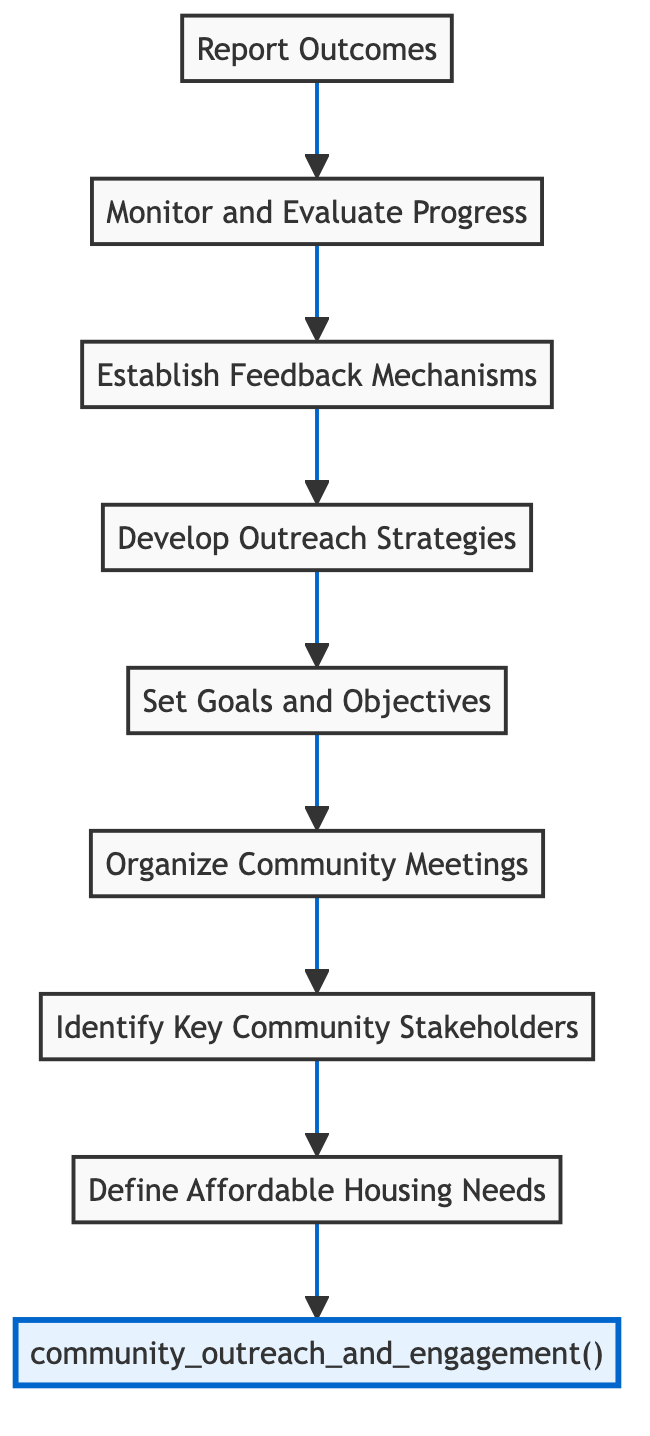What is the first step in the community outreach and engagement initiative? The flowchart begins from the bottom, indicating that the first step is "Define Affordable Housing Needs." This step is the initial point in the process before any further actions are taken.
Answer: Define Affordable Housing Needs How many steps are there in the initiative? Counting all the filled nodes in the flowchart, there are a total of eight steps listed from "Report Outcomes" to "Define Affordable Housing Needs." Each step represents a distinct action in the process.
Answer: Eight What happens after establishing feedback mechanisms? According to the flowchart, after "Establish Feedback Mechanisms," the next step is "Develop Outreach Strategies." This indicates a direct connection in the process leading to developing specific approaches based on feedback received.
Answer: Develop Outreach Strategies Which step immediately follows the monitoring and evaluating progress? In the flowchart, "Report Outcomes" is the step that immediately follows "Monitor and Evaluate Progress." This shows that after evaluating the initiatives, the results need to be compiled and shared.
Answer: Report Outcomes What is the final step in the flowchart? The last step in the flowchart is "Report Outcomes," which concludes the community outreach and engagement process. This step highlights the importance of transparency and accountability to stakeholders.
Answer: Report Outcomes Identify the node that comes before setting goals and objectives. The node directly before "Set Goals and Objectives" in the flowchart is "Develop Outreach Strategies." This shows that outreach strategies are essential to meet the goals and objectives established later.
Answer: Develop Outreach Strategies What are the two steps that come after identifying key community stakeholders? The steps that follow "Identify Key Community Stakeholders" are "Organize Community Meetings" and "Set Goals and Objectives." This shows a sequence where stakeholder engagement leads to organizing community interactions and setting targets.
Answer: Organize Community Meetings, Set Goals and Objectives Which step involves assessing community needs? The step that involves assessing community needs is "Define Affordable Housing Needs." This step focuses on understanding the specific housing requirements of the community through surveys and analysis.
Answer: Define Affordable Housing Needs What is the connection between monitoring and evaluating progress and reporting outcomes? "Monitor and Evaluate Progress" leads directly to "Report Outcomes," indicating that after assessing the initiative's effectiveness, the results should be reported to stakeholders and the public. This connection emphasizes the cycle of evaluation and reporting.
Answer: Report Outcomes 